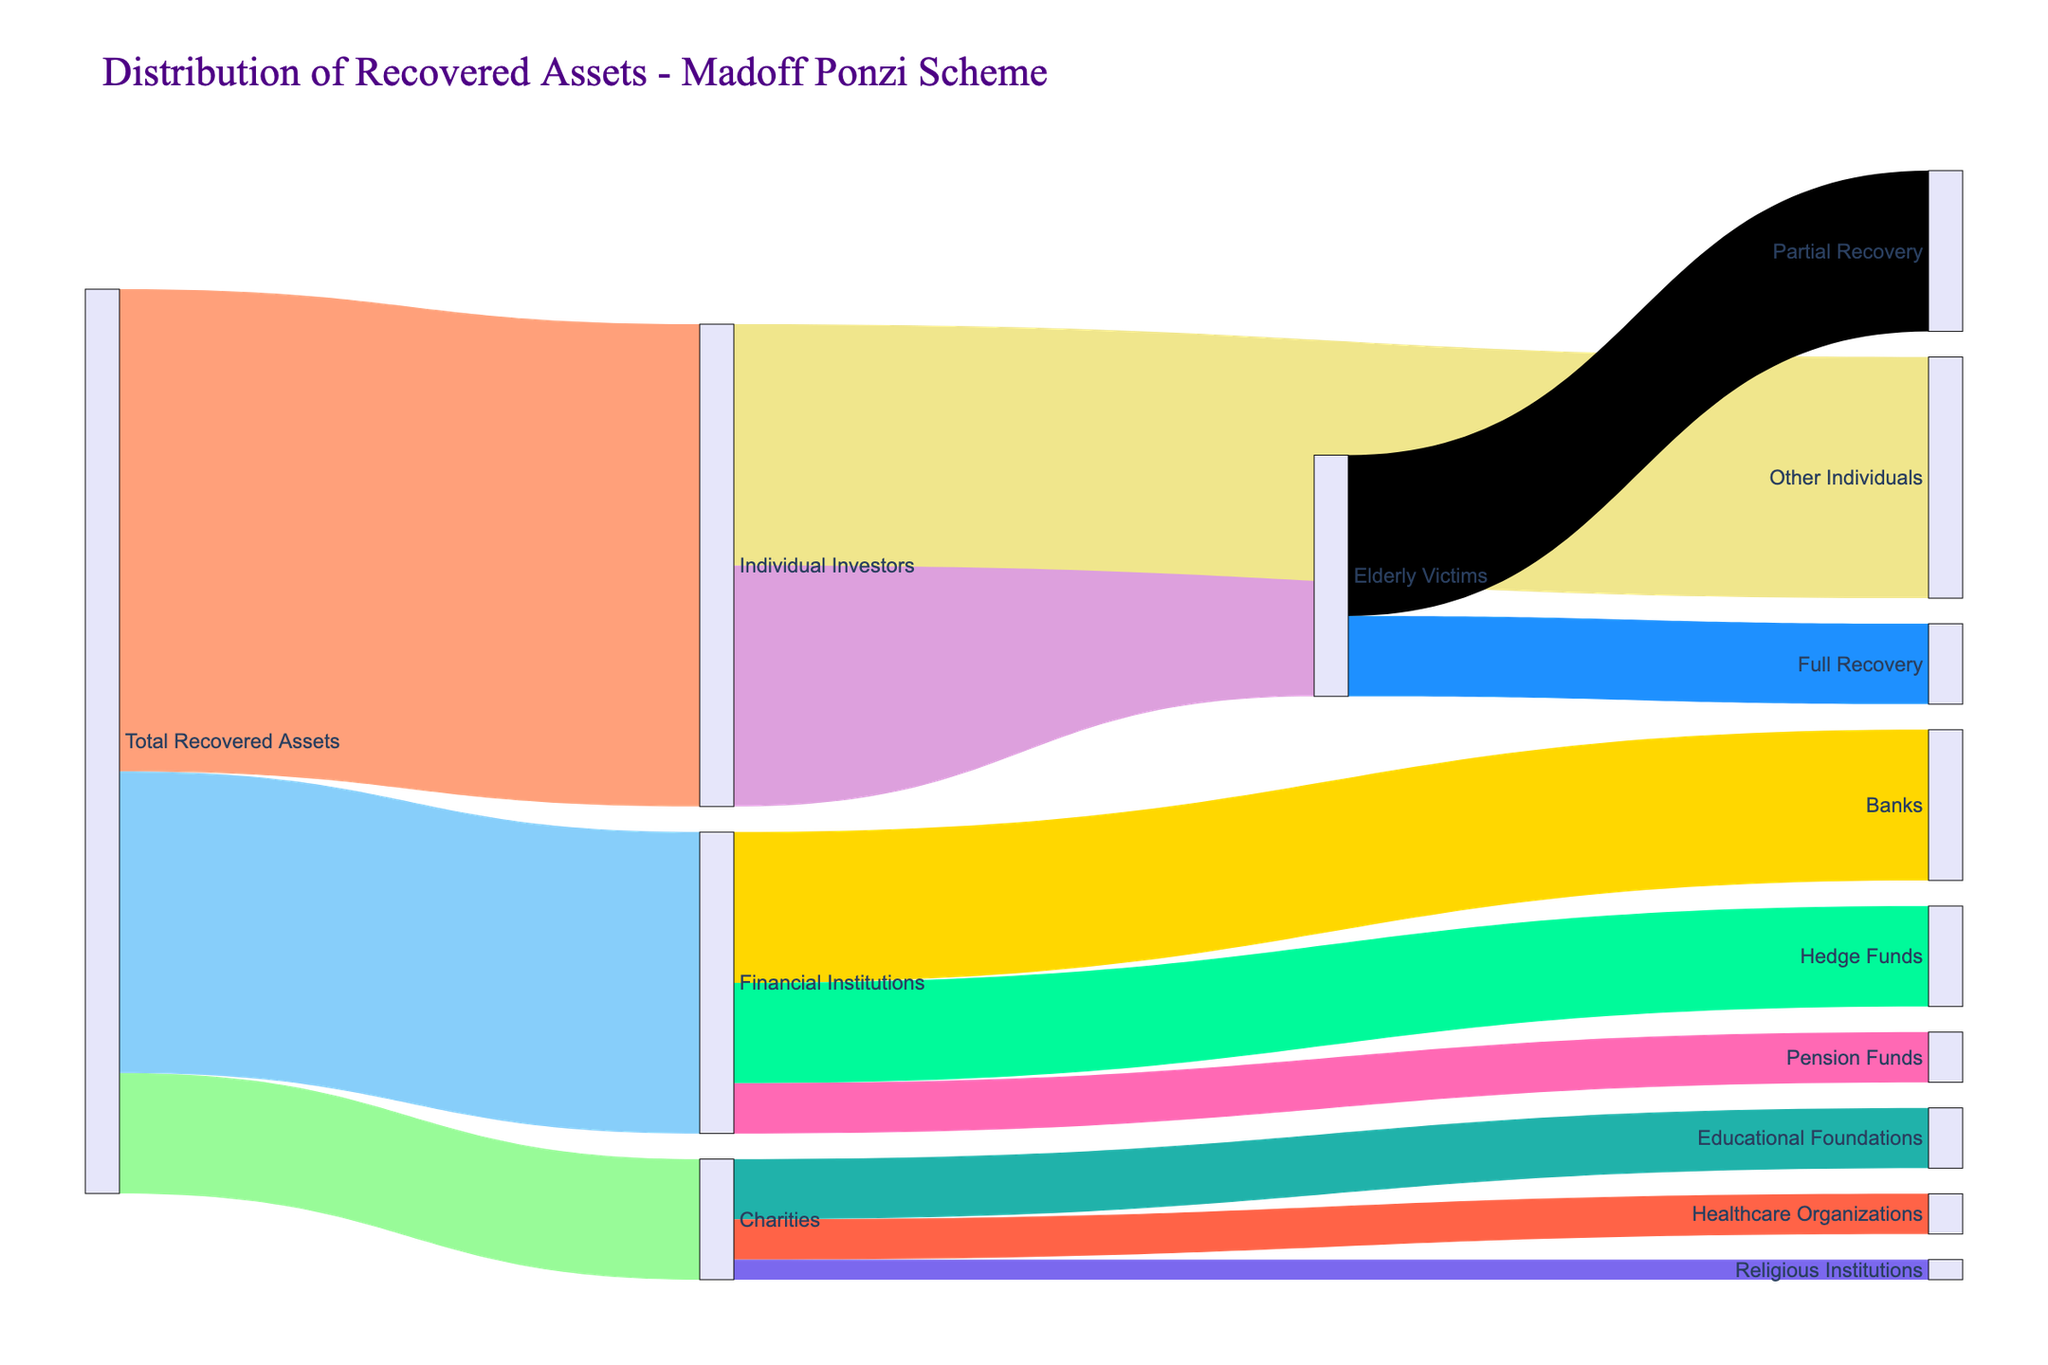what is the total value of assets recovered from the Madoff Ponzi scheme? The Sankey Diagram shows the recovered assets flowing from "Total Recovered Assets" to different categories. The values flowing from "Total Recovered Assets" are 4800 + 1200 + 3000. Adding these gives us the total value.
Answer: 9000 What portion of the total recovered assets went to individual investors? From the Sankey Diagram, "Individual Investors" received 4800 out of the total 9000 recovered. The portion can be calculated as 4800/9000. Simplifying this fraction gives us the answer.
Answer: 53.33% How much did the elderly victims recover in total? According to the Sankey Diagram, "Elderly Victims" received flows from "Individual Investors" with values 800 (Full Recovery) and 1600 (Partial Recovery). Adding these values together gives us the total.
Answer: 2400 Which category among the charities received the least amount of recovered assets? The Sankey Diagram shows the breakdown under "Charities" to "Educational Foundations" (600), "Healthcare Organizations" (400), and "Religious Institutions" (200). Comparing these values, the smallest amount is 200.
Answer: Religious Institutions How do the amounts recovered by Banks compare to Hedge Funds? The Sankey Diagram shows values to "Banks" as 1500 and to "Hedge Funds" as 1000. Comparing these, Banks received more.
Answer: Banks recovered more What percentage of the total recovered assets did financial institutions receive? Financial Institutions received 3000 out of the total 9000 recovered assets. The percentage is calculated as (3000/9000) * 100. This calculation gives the result directly.
Answer: 33.33% What is the total value received by non-individual entities, including both charities and financial institutions? The amounts under "Charities" are 1200 and "Financial Institutions" are 3000. Adding these values together gives us the total amount for non-individual entities.
Answer: 4200 How much of the Individual Investors' recovered assets were partially recovered by elderly victims? The Sankey Diagram indicates that "Partial Recovery" for "Elderly Victims" under "Individual Investors" is shown as 1600. This is the amount we seek.
Answer: 1600 